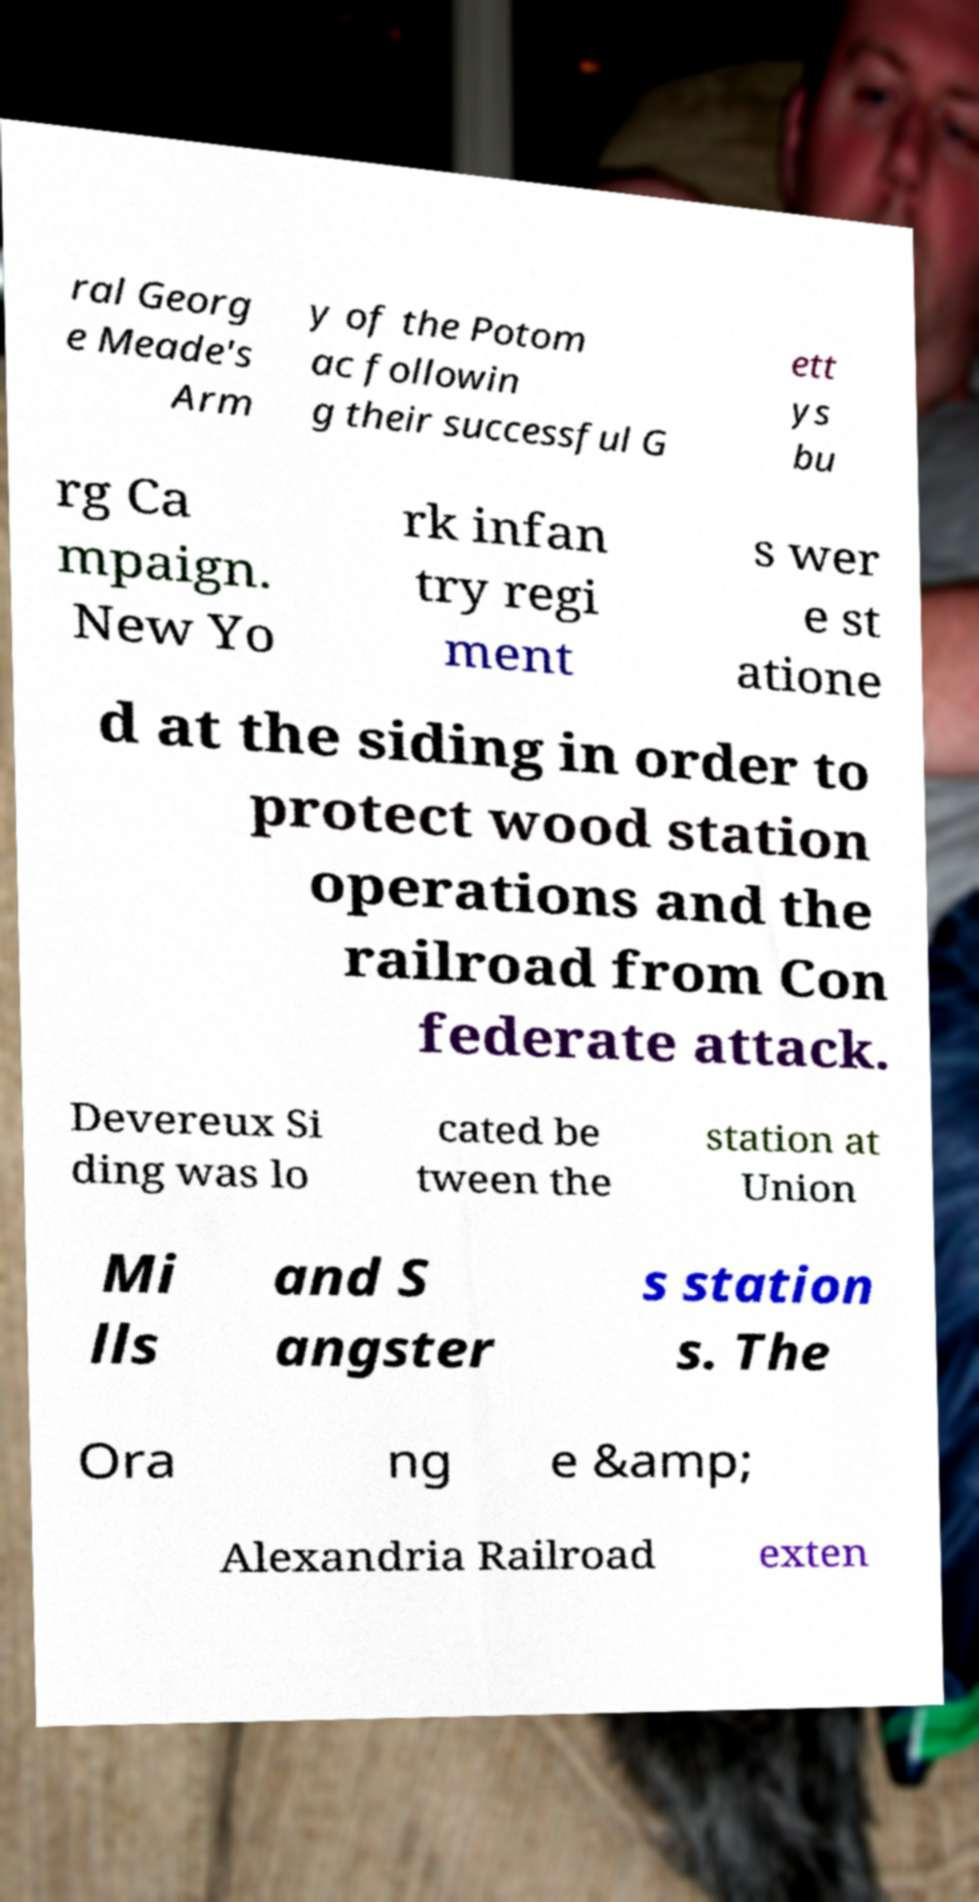There's text embedded in this image that I need extracted. Can you transcribe it verbatim? ral Georg e Meade's Arm y of the Potom ac followin g their successful G ett ys bu rg Ca mpaign. New Yo rk infan try regi ment s wer e st atione d at the siding in order to protect wood station operations and the railroad from Con federate attack. Devereux Si ding was lo cated be tween the station at Union Mi lls and S angster s station s. The Ora ng e &amp; Alexandria Railroad exten 